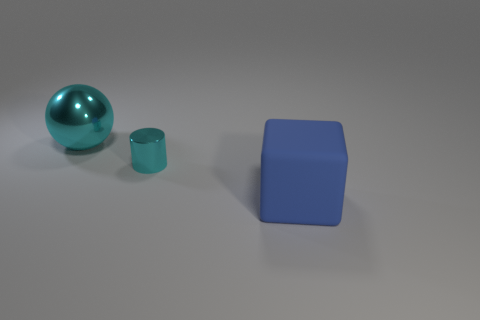Is there any other thing that is the same material as the blue block?
Ensure brevity in your answer.  No. Are there any other things that have the same shape as the large cyan thing?
Offer a terse response. No. What is the material of the sphere?
Offer a terse response. Metal. How many other things are made of the same material as the block?
Give a very brief answer. 0. Does the big sphere have the same material as the large object on the right side of the cyan shiny cylinder?
Give a very brief answer. No. Is the number of large cyan shiny objects that are in front of the cyan cylinder less than the number of things that are in front of the large cyan sphere?
Make the answer very short. Yes. What color is the big thing to the left of the big matte cube?
Provide a short and direct response. Cyan. How many other things are there of the same color as the tiny cylinder?
Keep it short and to the point. 1. There is a cyan object that is behind the cylinder; does it have the same size as the large rubber thing?
Offer a terse response. Yes. How many large cubes are in front of the big blue block?
Keep it short and to the point. 0. 